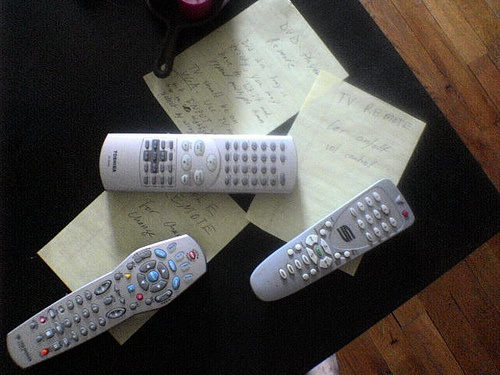Describe the objects in this image and their specific colors. I can see remote in black, darkgray, gray, and lavender tones, remote in black, gray, and darkgray tones, and remote in black, gray, and darkgray tones in this image. 